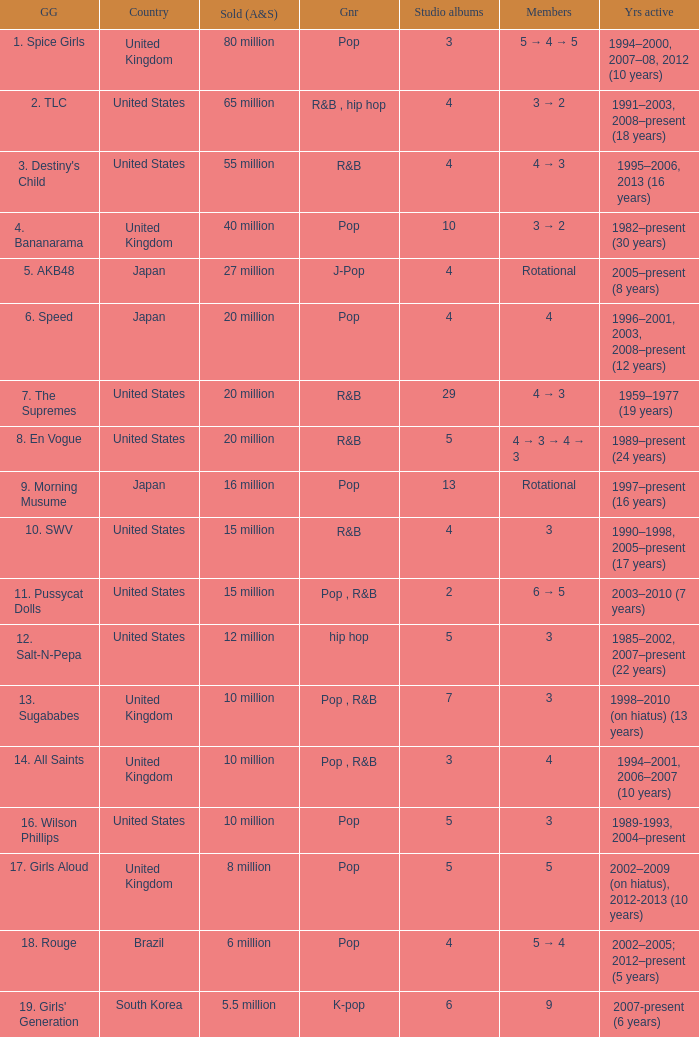How many members were in the group that sold 65 million albums and singles? 3 → 2. 